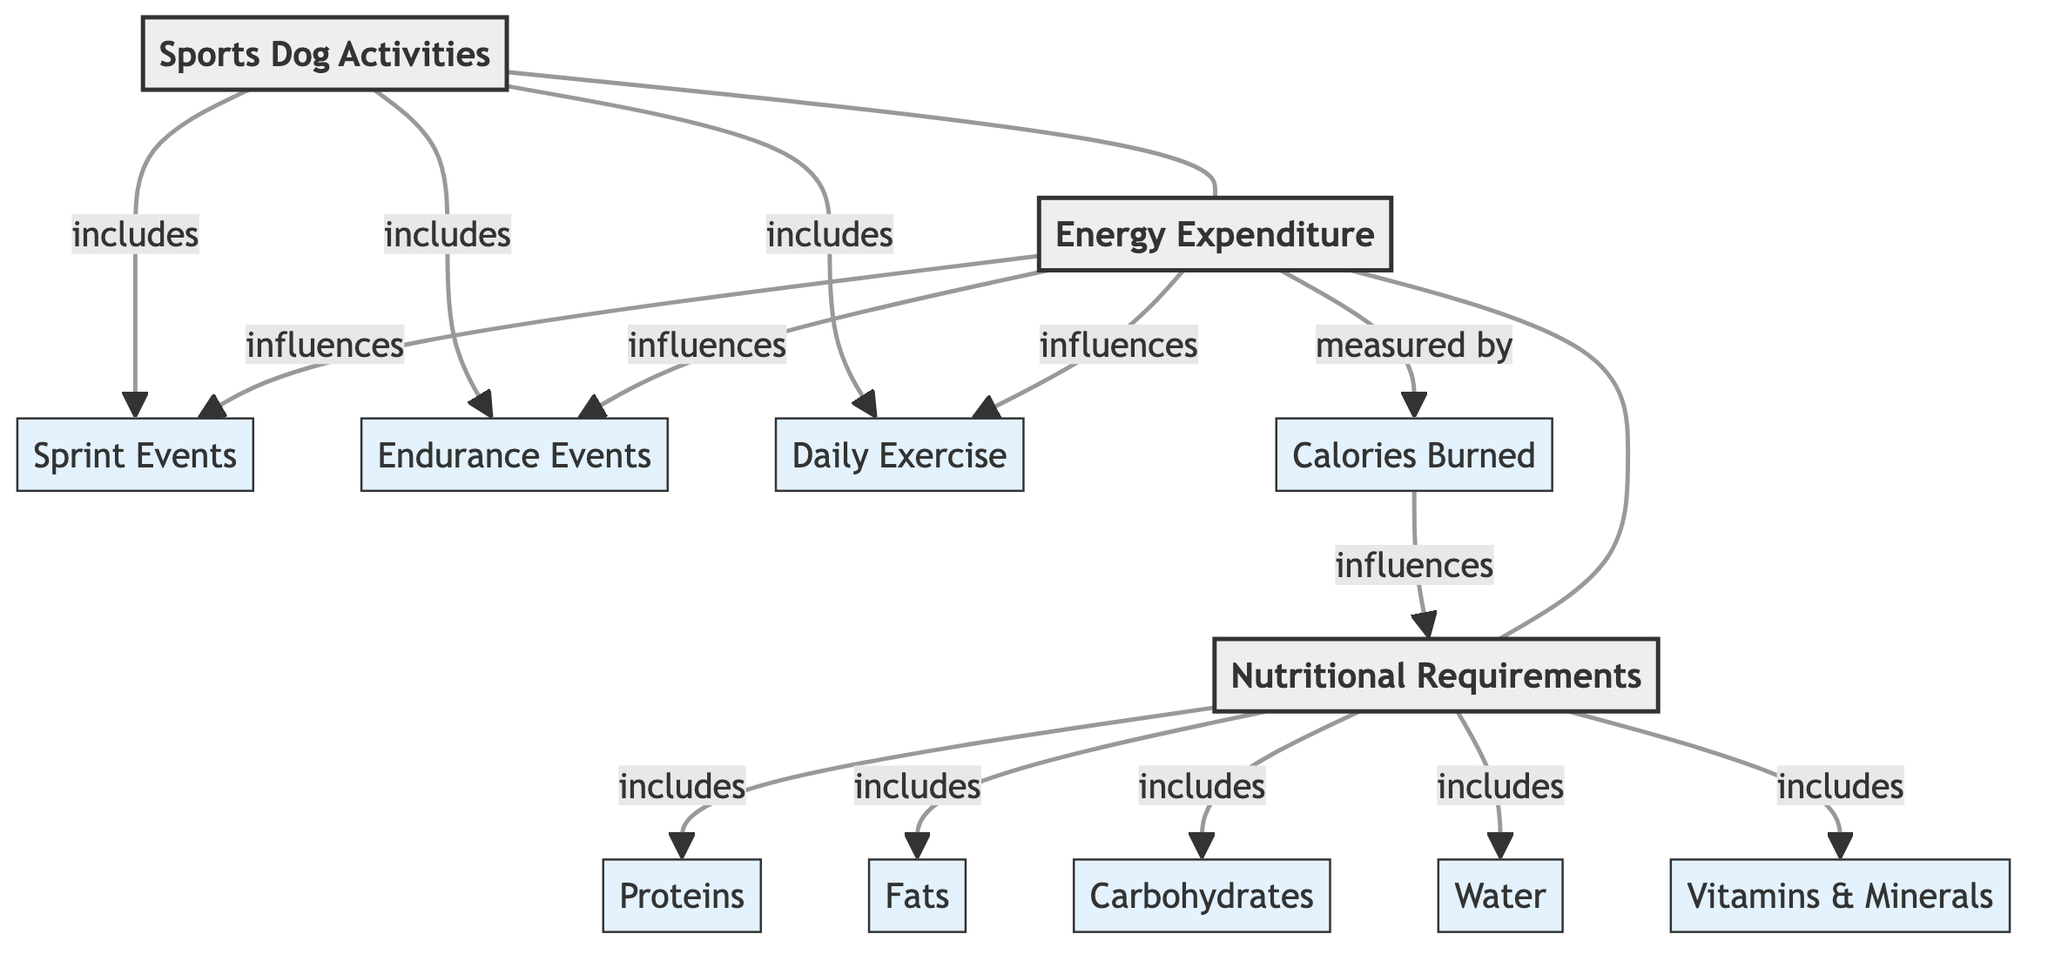What are the three main categories in the diagram? The diagram outlines three main categories: Sports Dog Activities, Energy Expenditure, and Nutritional Requirements. These are the central nodes connected in the diagram.
Answer: Sports Dog Activities, Energy Expenditure, Nutritional Requirements How many subcategories are listed under Nutritional Requirements? The Nutritional Requirements category includes five subcategories: Proteins, Fats, Carbohydrates, Water, and Vitamins & Minerals. Counting these gives a total of five.
Answer: 5 What influences Daily Exercise in the diagram? The diagram indicates that Energy Expenditure influences Daily Exercise. This connection shows how the amount of energy spent impacts the exercise routines of sports dogs.
Answer: Energy Expenditure Which category includes Sprint Events? The Sprint Events subcategory is included under the Sports Dog Activities category, as shown by the direct connection between them in the diagram.
Answer: Sports Dog Activities What is measured by the Calories Burned? According to the diagram, Calories Burned is connected to Nutritional Requirements, suggesting that the quantity of calories burned directly influences the nutritional needs of sports dogs.
Answer: Nutritional Requirements How many activities are included in the Sports Dog Activities category? The Sports Dog Activities category includes three activities: Sprint Events, Endurance Events, and Daily Exercise. Thus, there are three activities total.
Answer: 3 Which nutritional component influences Calories Burned? The diagram indicates that Nutritional Requirements overall plays a role in influencing Calories Burned. The connection indicates that the nutrients provided affect energy expenditure.
Answer: Nutritional Requirements What are the main influences on Endurance Events? The influences on Endurance Events are illustrated in the diagram by Energy Expenditure, which suggests that how much energy is spent affects endurance training in dogs.
Answer: Energy Expenditure 